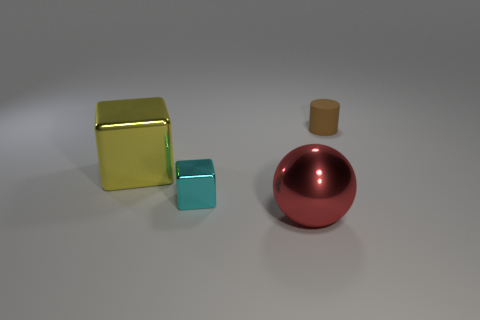Add 3 large yellow metallic objects. How many objects exist? 7 Subtract 0 cyan spheres. How many objects are left? 4 Subtract all cylinders. How many objects are left? 3 Subtract all gray spheres. Subtract all green blocks. How many spheres are left? 1 Subtract all red balls. How many yellow blocks are left? 1 Subtract all matte cylinders. Subtract all red objects. How many objects are left? 2 Add 2 tiny cubes. How many tiny cubes are left? 3 Add 2 big brown shiny balls. How many big brown shiny balls exist? 2 